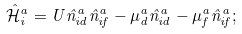<formula> <loc_0><loc_0><loc_500><loc_500>\mathcal { \hat { H } } _ { i } ^ { a } = U \hat { n } _ { i d } ^ { a } \hat { n } _ { i f } ^ { a } - \mu _ { d } ^ { a } \hat { n } _ { i d } ^ { a } - \mu _ { f } ^ { a } \hat { n } _ { i f } ^ { a } ;</formula> 